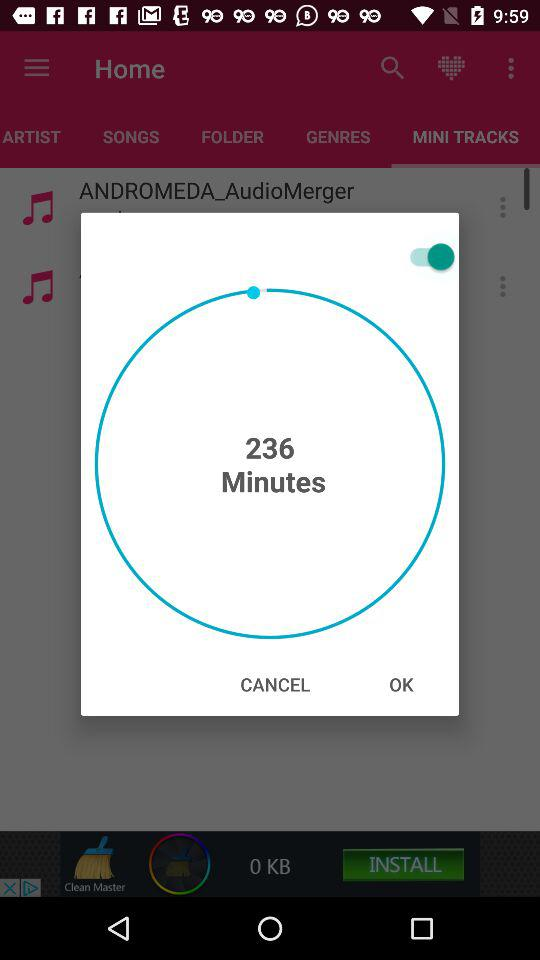Which tab is currently selected? The currently selected tab is "MINI TRACKS". 